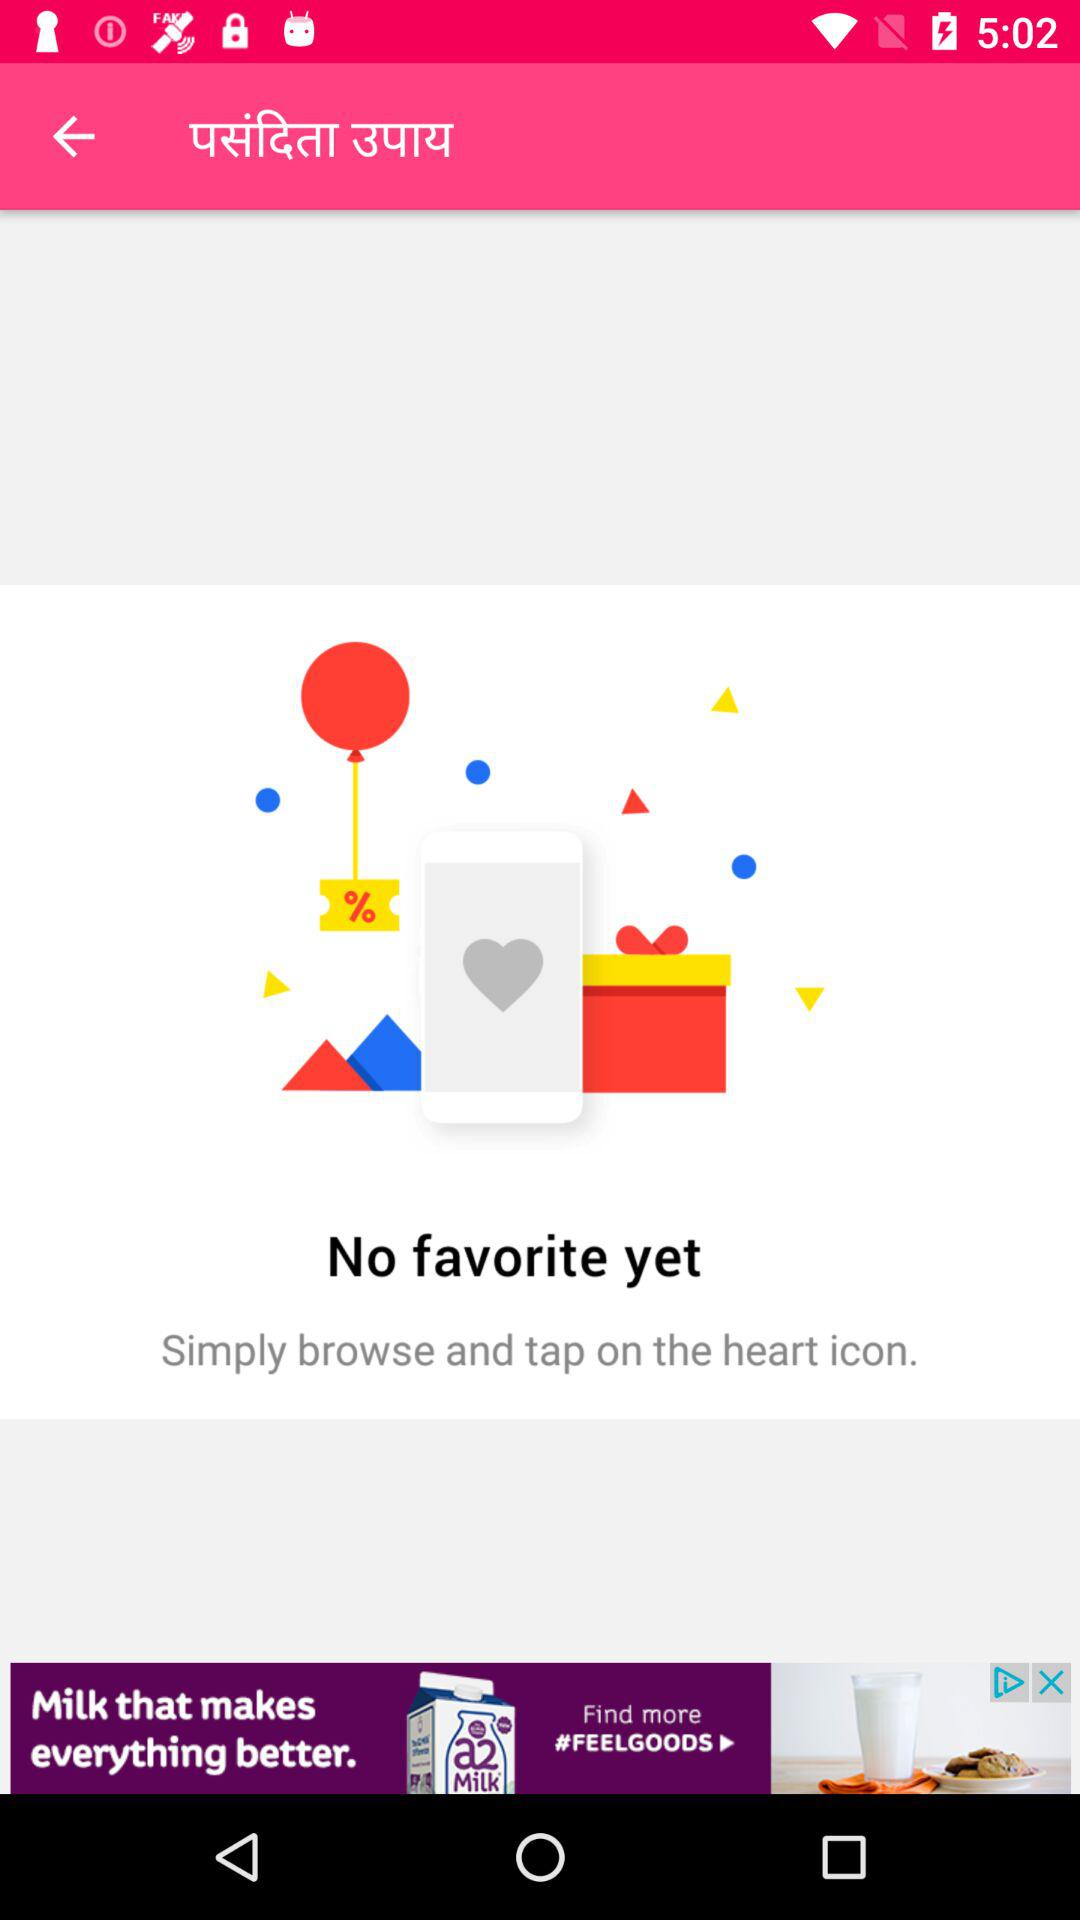How many favorites are there?
Answer the question using a single word or phrase. 0 